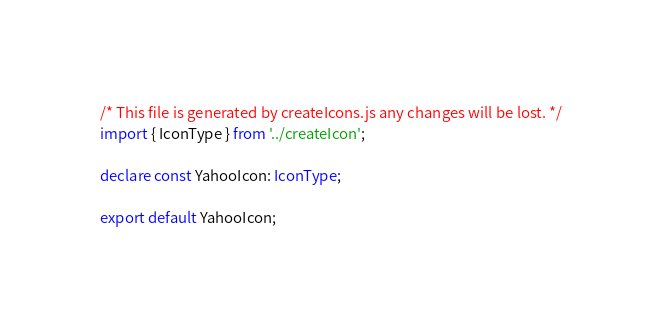Convert code to text. <code><loc_0><loc_0><loc_500><loc_500><_TypeScript_>/* This file is generated by createIcons.js any changes will be lost. */
import { IconType } from '../createIcon';

declare const YahooIcon: IconType;

export default YahooIcon;
</code> 